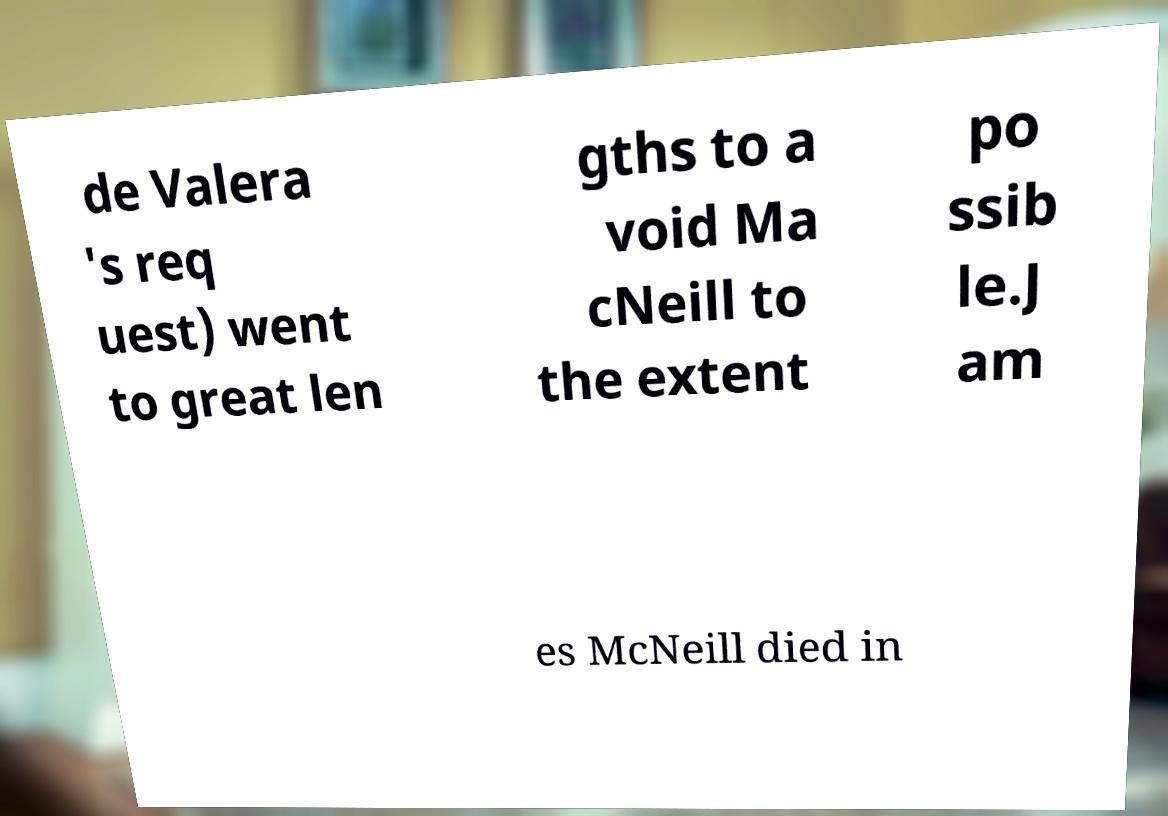There's text embedded in this image that I need extracted. Can you transcribe it verbatim? de Valera 's req uest) went to great len gths to a void Ma cNeill to the extent po ssib le.J am es McNeill died in 